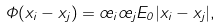<formula> <loc_0><loc_0><loc_500><loc_500>\Phi ( x _ { i } - x _ { j } ) = \sigma _ { i } \sigma _ { j } E _ { 0 } | x _ { i } - x _ { j } | ,</formula> 